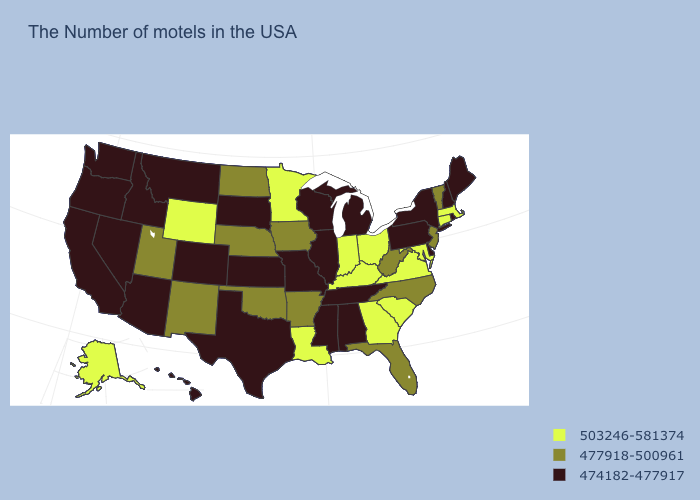Among the states that border Texas , which have the highest value?
Be succinct. Louisiana. Among the states that border Wyoming , does Nebraska have the highest value?
Answer briefly. Yes. What is the value of Georgia?
Be succinct. 503246-581374. What is the highest value in states that border Wisconsin?
Keep it brief. 503246-581374. Does the first symbol in the legend represent the smallest category?
Keep it brief. No. Name the states that have a value in the range 474182-477917?
Short answer required. Maine, Rhode Island, New Hampshire, New York, Delaware, Pennsylvania, Michigan, Alabama, Tennessee, Wisconsin, Illinois, Mississippi, Missouri, Kansas, Texas, South Dakota, Colorado, Montana, Arizona, Idaho, Nevada, California, Washington, Oregon, Hawaii. Name the states that have a value in the range 503246-581374?
Keep it brief. Massachusetts, Connecticut, Maryland, Virginia, South Carolina, Ohio, Georgia, Kentucky, Indiana, Louisiana, Minnesota, Wyoming, Alaska. What is the value of Delaware?
Short answer required. 474182-477917. Which states hav the highest value in the Northeast?
Keep it brief. Massachusetts, Connecticut. What is the lowest value in states that border Minnesota?
Short answer required. 474182-477917. Name the states that have a value in the range 477918-500961?
Concise answer only. Vermont, New Jersey, North Carolina, West Virginia, Florida, Arkansas, Iowa, Nebraska, Oklahoma, North Dakota, New Mexico, Utah. Name the states that have a value in the range 474182-477917?
Answer briefly. Maine, Rhode Island, New Hampshire, New York, Delaware, Pennsylvania, Michigan, Alabama, Tennessee, Wisconsin, Illinois, Mississippi, Missouri, Kansas, Texas, South Dakota, Colorado, Montana, Arizona, Idaho, Nevada, California, Washington, Oregon, Hawaii. Does the first symbol in the legend represent the smallest category?
Short answer required. No. Name the states that have a value in the range 503246-581374?
Quick response, please. Massachusetts, Connecticut, Maryland, Virginia, South Carolina, Ohio, Georgia, Kentucky, Indiana, Louisiana, Minnesota, Wyoming, Alaska. Does Kentucky have the highest value in the USA?
Write a very short answer. Yes. 